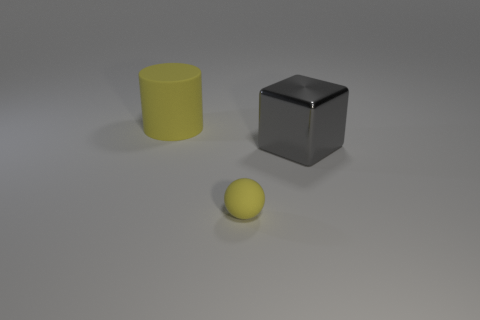Assuming these objects have weight, which would be heavier? Assuming they are made of the same material, the cube would be the heaviest due to its larger volume compared to the cylindrical and spherical objects. However, without specific material density and volume, we cannot determine the exact weight. 